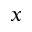<formula> <loc_0><loc_0><loc_500><loc_500>x</formula> 